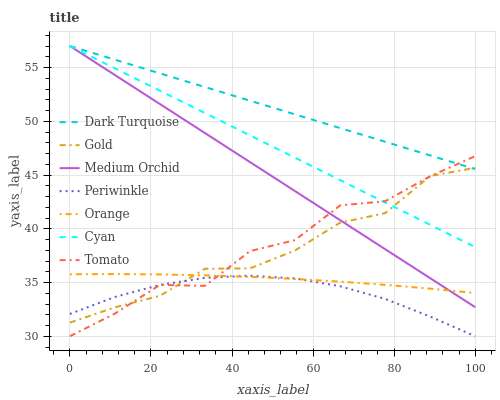Does Periwinkle have the minimum area under the curve?
Answer yes or no. Yes. Does Dark Turquoise have the maximum area under the curve?
Answer yes or no. Yes. Does Gold have the minimum area under the curve?
Answer yes or no. No. Does Gold have the maximum area under the curve?
Answer yes or no. No. Is Cyan the smoothest?
Answer yes or no. Yes. Is Tomato the roughest?
Answer yes or no. Yes. Is Gold the smoothest?
Answer yes or no. No. Is Gold the roughest?
Answer yes or no. No. Does Tomato have the lowest value?
Answer yes or no. Yes. Does Gold have the lowest value?
Answer yes or no. No. Does Cyan have the highest value?
Answer yes or no. Yes. Does Gold have the highest value?
Answer yes or no. No. Is Orange less than Cyan?
Answer yes or no. Yes. Is Medium Orchid greater than Periwinkle?
Answer yes or no. Yes. Does Medium Orchid intersect Gold?
Answer yes or no. Yes. Is Medium Orchid less than Gold?
Answer yes or no. No. Is Medium Orchid greater than Gold?
Answer yes or no. No. Does Orange intersect Cyan?
Answer yes or no. No. 